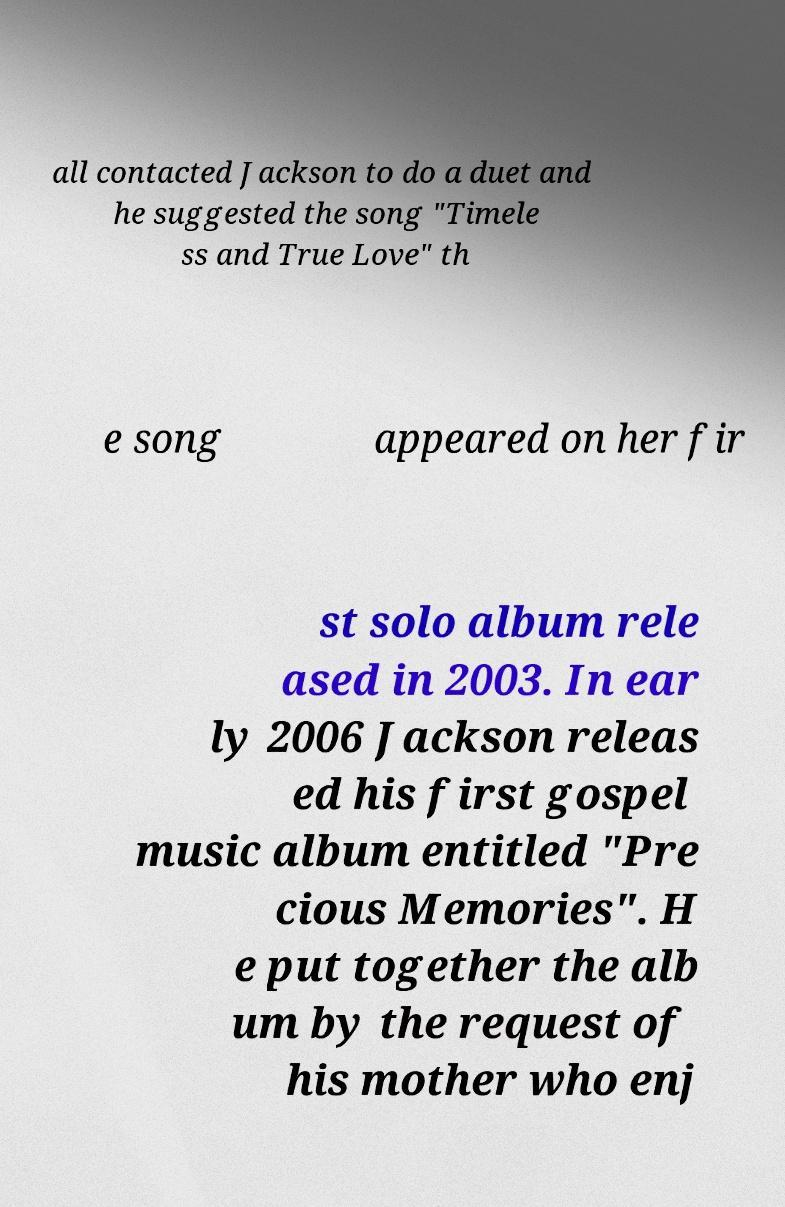Can you read and provide the text displayed in the image?This photo seems to have some interesting text. Can you extract and type it out for me? all contacted Jackson to do a duet and he suggested the song "Timele ss and True Love" th e song appeared on her fir st solo album rele ased in 2003. In ear ly 2006 Jackson releas ed his first gospel music album entitled "Pre cious Memories". H e put together the alb um by the request of his mother who enj 